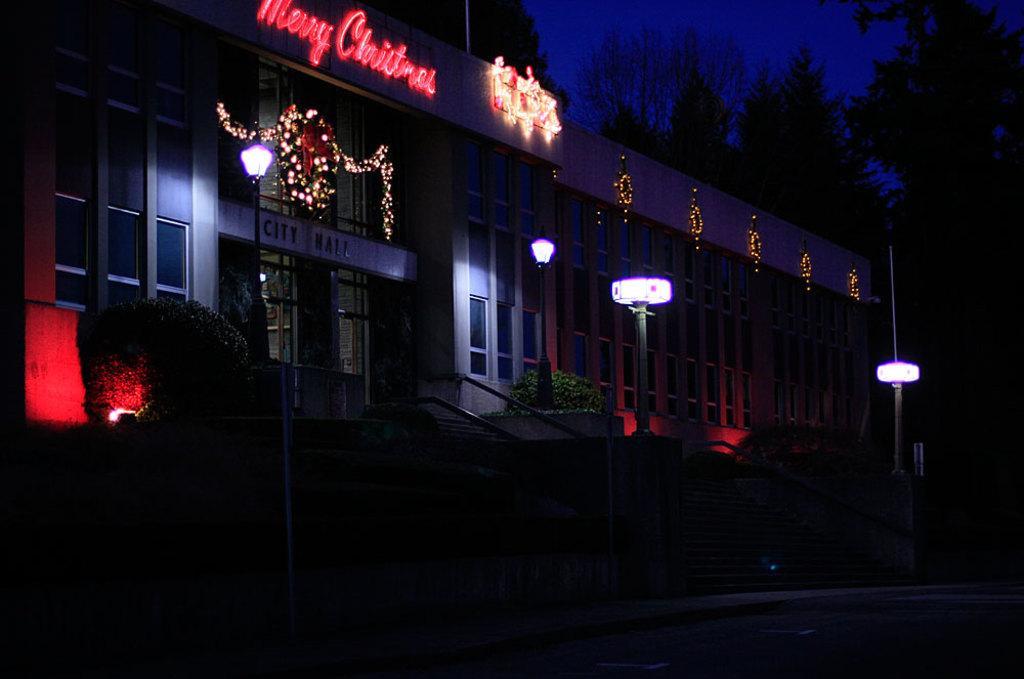Can you describe this image briefly? In this image we can see a building with doors and windows and there are some decorative lights attached to the building. We can see few light poles and there are some plants and trees and we can see the sky. 